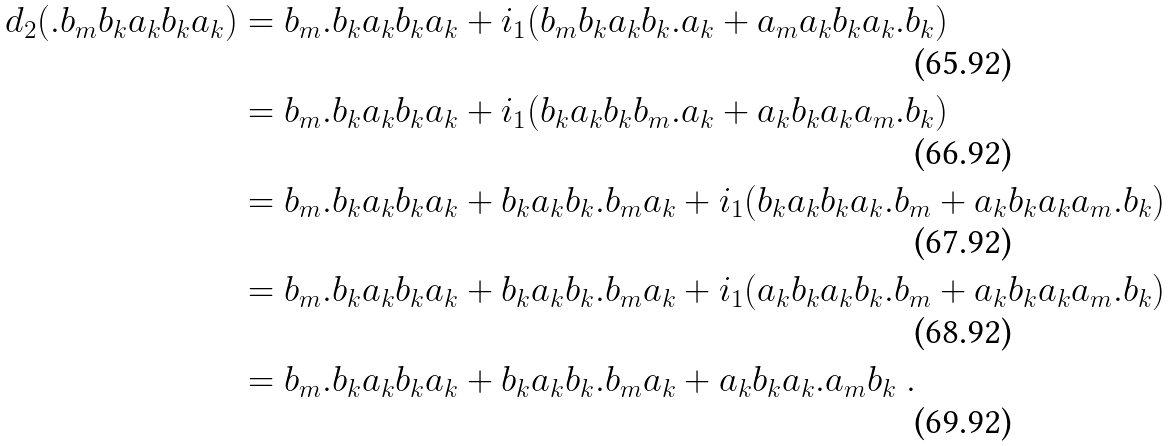Convert formula to latex. <formula><loc_0><loc_0><loc_500><loc_500>d _ { 2 } ( . b _ { m } b _ { k } a _ { k } b _ { k } a _ { k } ) & = b _ { m } . b _ { k } a _ { k } b _ { k } a _ { k } + i _ { 1 } ( b _ { m } b _ { k } a _ { k } b _ { k } . a _ { k } + a _ { m } a _ { k } b _ { k } a _ { k } . b _ { k } ) \\ & = b _ { m } . b _ { k } a _ { k } b _ { k } a _ { k } + i _ { 1 } ( b _ { k } a _ { k } b _ { k } b _ { m } . a _ { k } + a _ { k } b _ { k } a _ { k } a _ { m } . b _ { k } ) \\ & = b _ { m } . b _ { k } a _ { k } b _ { k } a _ { k } + b _ { k } a _ { k } b _ { k } . b _ { m } a _ { k } + i _ { 1 } ( b _ { k } a _ { k } b _ { k } a _ { k } . b _ { m } + a _ { k } b _ { k } a _ { k } a _ { m } . b _ { k } ) \\ & = b _ { m } . b _ { k } a _ { k } b _ { k } a _ { k } + b _ { k } a _ { k } b _ { k } . b _ { m } a _ { k } + i _ { 1 } ( a _ { k } b _ { k } a _ { k } b _ { k } . b _ { m } + a _ { k } b _ { k } a _ { k } a _ { m } . b _ { k } ) \\ & = b _ { m } . b _ { k } a _ { k } b _ { k } a _ { k } + b _ { k } a _ { k } b _ { k } . b _ { m } a _ { k } + a _ { k } b _ { k } a _ { k } . a _ { m } b _ { k } \ .</formula> 